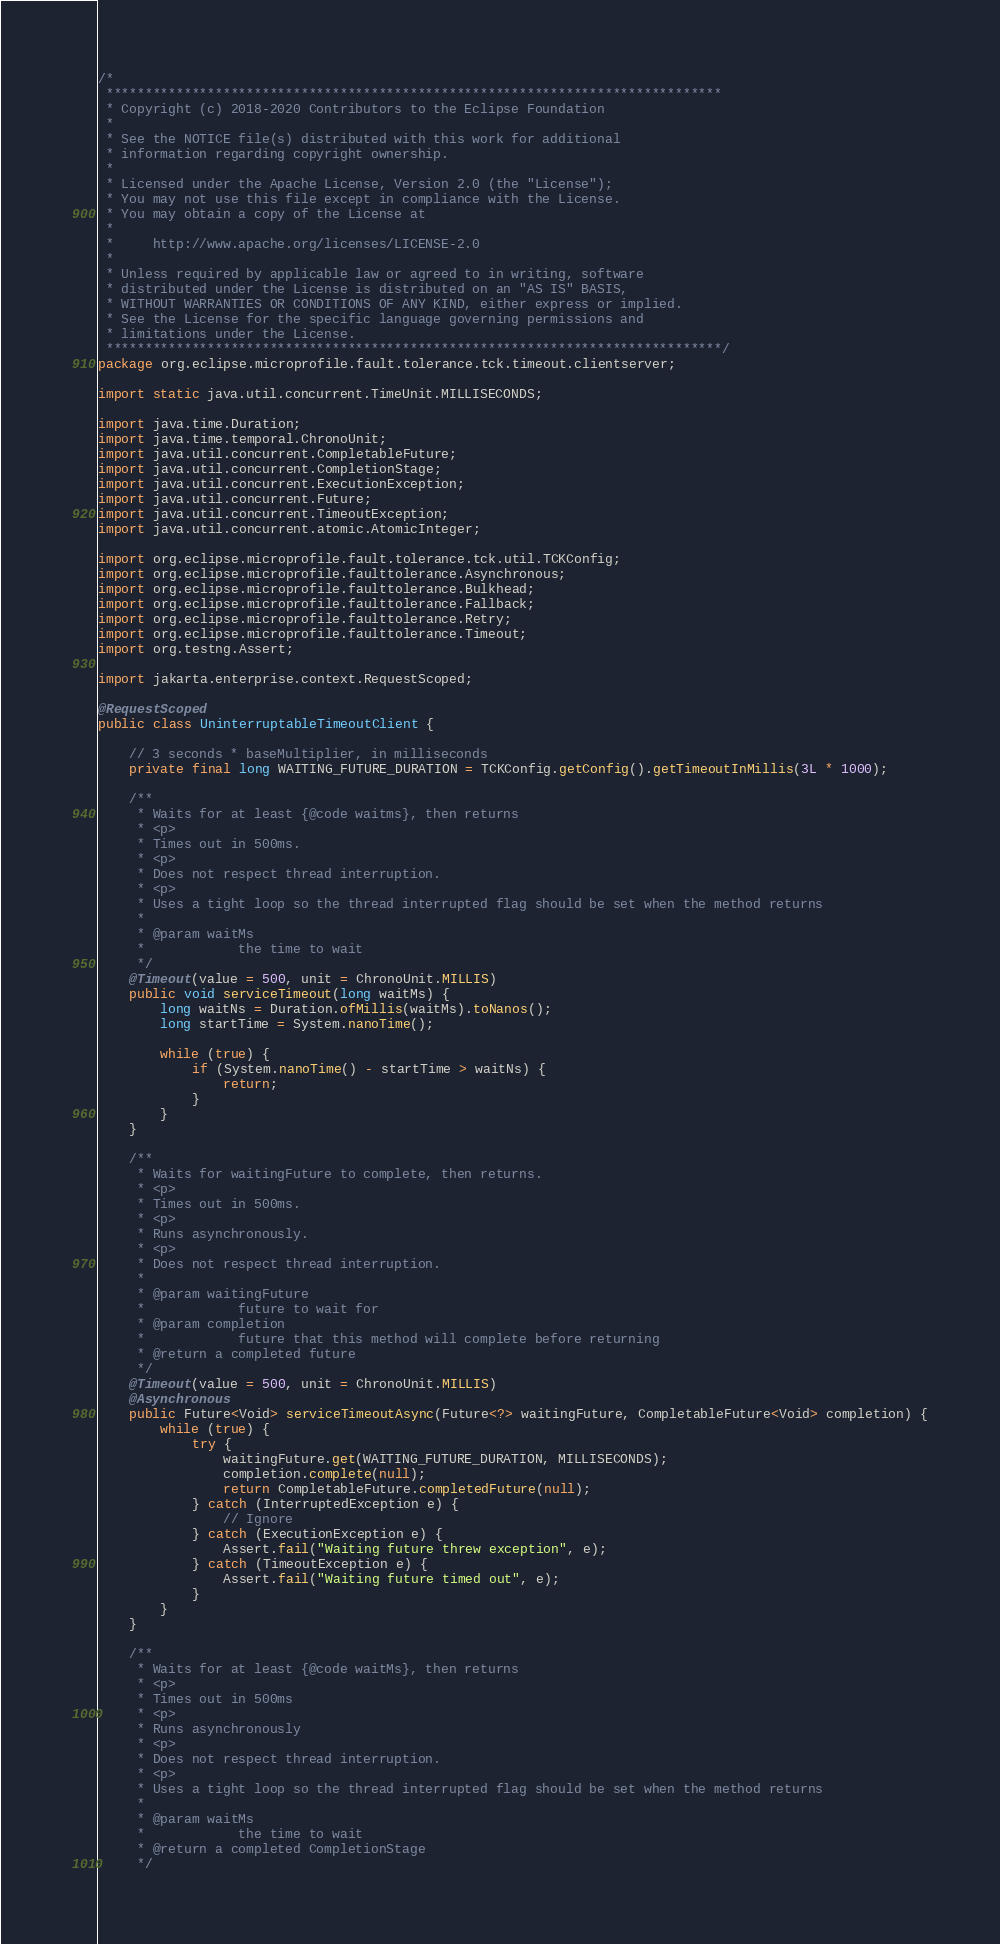<code> <loc_0><loc_0><loc_500><loc_500><_Java_>/*
 *******************************************************************************
 * Copyright (c) 2018-2020 Contributors to the Eclipse Foundation
 *
 * See the NOTICE file(s) distributed with this work for additional
 * information regarding copyright ownership.
 *
 * Licensed under the Apache License, Version 2.0 (the "License");
 * You may not use this file except in compliance with the License.
 * You may obtain a copy of the License at
 *
 *     http://www.apache.org/licenses/LICENSE-2.0
 *
 * Unless required by applicable law or agreed to in writing, software
 * distributed under the License is distributed on an "AS IS" BASIS,
 * WITHOUT WARRANTIES OR CONDITIONS OF ANY KIND, either express or implied.
 * See the License for the specific language governing permissions and
 * limitations under the License.
 *******************************************************************************/
package org.eclipse.microprofile.fault.tolerance.tck.timeout.clientserver;

import static java.util.concurrent.TimeUnit.MILLISECONDS;

import java.time.Duration;
import java.time.temporal.ChronoUnit;
import java.util.concurrent.CompletableFuture;
import java.util.concurrent.CompletionStage;
import java.util.concurrent.ExecutionException;
import java.util.concurrent.Future;
import java.util.concurrent.TimeoutException;
import java.util.concurrent.atomic.AtomicInteger;

import org.eclipse.microprofile.fault.tolerance.tck.util.TCKConfig;
import org.eclipse.microprofile.faulttolerance.Asynchronous;
import org.eclipse.microprofile.faulttolerance.Bulkhead;
import org.eclipse.microprofile.faulttolerance.Fallback;
import org.eclipse.microprofile.faulttolerance.Retry;
import org.eclipse.microprofile.faulttolerance.Timeout;
import org.testng.Assert;

import jakarta.enterprise.context.RequestScoped;

@RequestScoped
public class UninterruptableTimeoutClient {

    // 3 seconds * baseMultiplier, in milliseconds
    private final long WAITING_FUTURE_DURATION = TCKConfig.getConfig().getTimeoutInMillis(3L * 1000);

    /**
     * Waits for at least {@code waitms}, then returns
     * <p>
     * Times out in 500ms.
     * <p>
     * Does not respect thread interruption.
     * <p>
     * Uses a tight loop so the thread interrupted flag should be set when the method returns
     * 
     * @param waitMs
     *            the time to wait
     */
    @Timeout(value = 500, unit = ChronoUnit.MILLIS)
    public void serviceTimeout(long waitMs) {
        long waitNs = Duration.ofMillis(waitMs).toNanos();
        long startTime = System.nanoTime();

        while (true) {
            if (System.nanoTime() - startTime > waitNs) {
                return;
            }
        }
    }

    /**
     * Waits for waitingFuture to complete, then returns.
     * <p>
     * Times out in 500ms.
     * <p>
     * Runs asynchronously.
     * <p>
     * Does not respect thread interruption.
     * 
     * @param waitingFuture
     *            future to wait for
     * @param completion
     *            future that this method will complete before returning
     * @return a completed future
     */
    @Timeout(value = 500, unit = ChronoUnit.MILLIS)
    @Asynchronous
    public Future<Void> serviceTimeoutAsync(Future<?> waitingFuture, CompletableFuture<Void> completion) {
        while (true) {
            try {
                waitingFuture.get(WAITING_FUTURE_DURATION, MILLISECONDS);
                completion.complete(null);
                return CompletableFuture.completedFuture(null);
            } catch (InterruptedException e) {
                // Ignore
            } catch (ExecutionException e) {
                Assert.fail("Waiting future threw exception", e);
            } catch (TimeoutException e) {
                Assert.fail("Waiting future timed out", e);
            }
        }
    }

    /**
     * Waits for at least {@code waitMs}, then returns
     * <p>
     * Times out in 500ms
     * <p>
     * Runs asynchronously
     * <p>
     * Does not respect thread interruption.
     * <p>
     * Uses a tight loop so the thread interrupted flag should be set when the method returns
     * 
     * @param waitMs
     *            the time to wait
     * @return a completed CompletionStage
     */</code> 